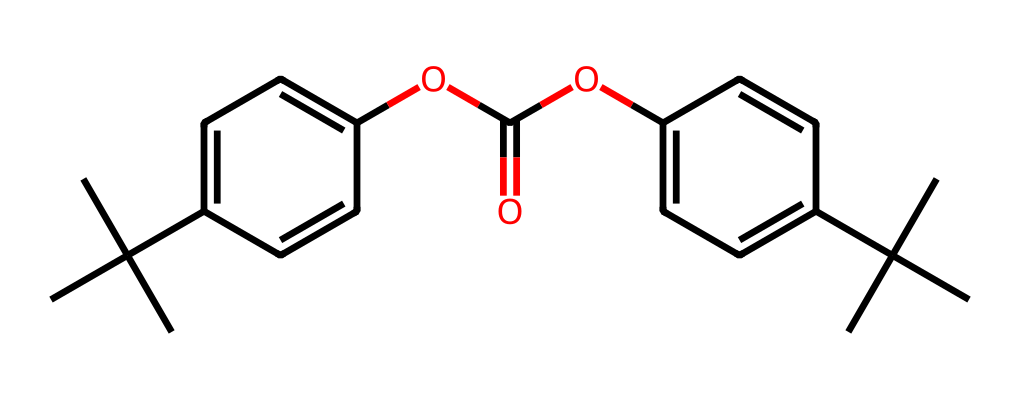What is the primary functional group in this structure? The structure contains an ester functional group, which is suggested by the presence of the carbonyl (C=O) adjacent to an alkoxy (-O-). This is characteristic of the linkage present in polycarbonates.
Answer: ester How many aromatic rings are present in the molecule? The molecule contains two distinct aromatic rings, identified by the presence of alternating double bonds in the cyclic structure. Both rings are functionalized with alkyl groups, which helps to denote their aromatic nature.
Answer: 2 What is the total number of carbon atoms in this structure? By counting each carbon atom visible in the structure, including those in the aromatic rings and the aliphatic chains, we find a total of 20 carbon atoms. Careful enumeration is necessary to ensure all carbons are considered.
Answer: 20 What type of polymer does the structure represent? Polycarbonate is identified through its unique structure that includes carbonate linkages and provides properties suitable for applications such as eyewear. The repeating unit typically has the carbonate bond characteristic of this type of polymer.
Answer: polycarbonate How does the bulky group affect the physical properties of this polymer? The presence of bulky alkyl groups in the structure enhances the impact resistance and allows for better transparency in the polymer, which is critical for military eyewear to ensure both durability and visibility while minimizing distortion.
Answer: impact resistance Which part of the molecule contributes to its high refractive index? The presence of aromatic rings in the structure contributes to a high refractive index due to the delocalization of π-electrons, which enhances the material's optical clarity, a necessary feature for eyewear applications.
Answer: aromatic rings 